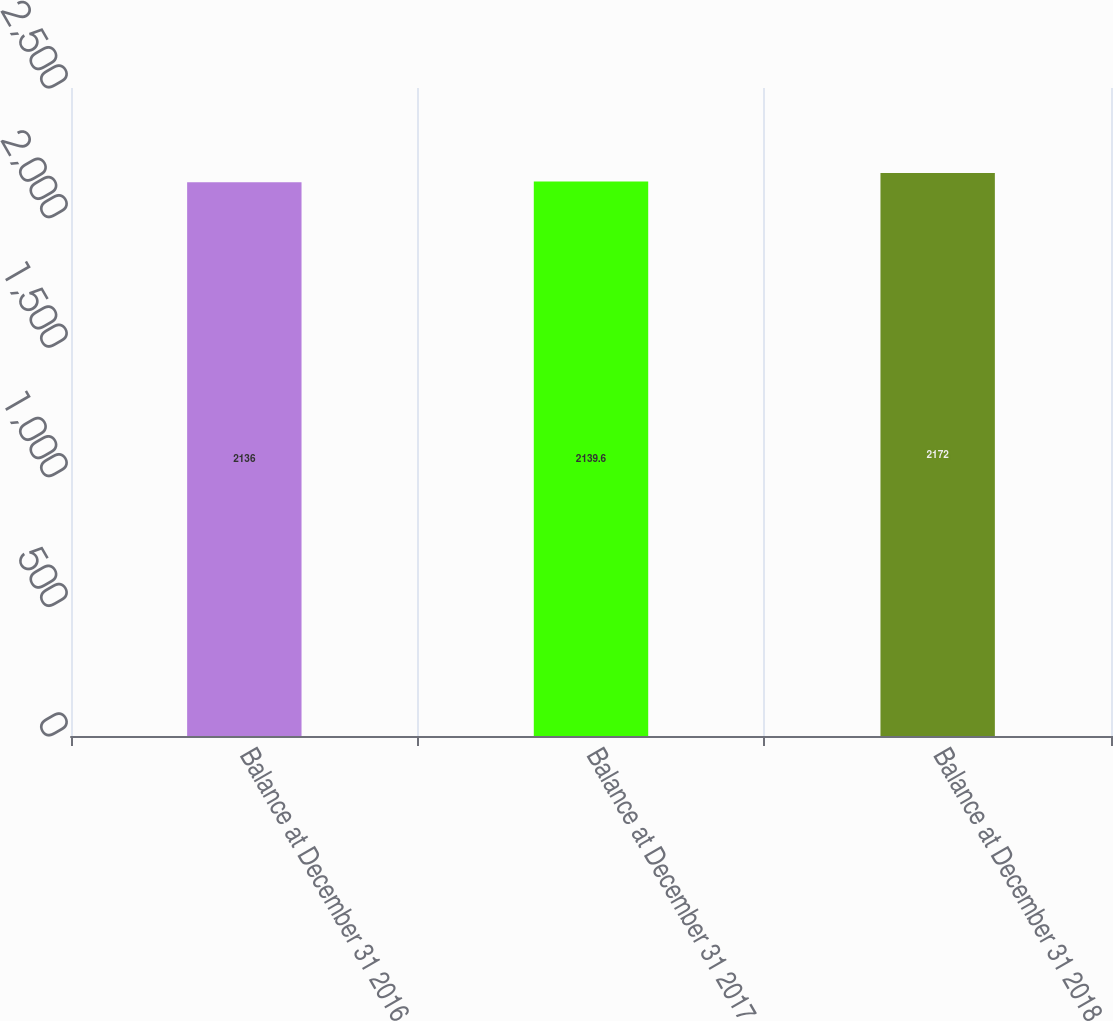<chart> <loc_0><loc_0><loc_500><loc_500><bar_chart><fcel>Balance at December 31 2016<fcel>Balance at December 31 2017<fcel>Balance at December 31 2018<nl><fcel>2136<fcel>2139.6<fcel>2172<nl></chart> 